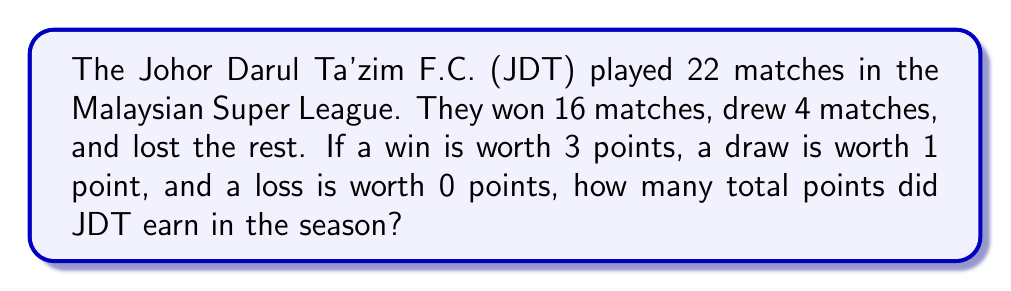What is the answer to this math problem? Let's approach this step-by-step:

1. First, let's identify the given information:
   - Total matches played: 22
   - Matches won: 16
   - Matches drawn: 4
   - Matches lost: 22 - 16 - 4 = 2

2. Now, let's set up our equation:
   $$ \text{Total Points} = (3 \times \text{Wins}) + (1 \times \text{Draws}) + (0 \times \text{Losses}) $$

3. Let's substitute the values:
   $$ \text{Total Points} = (3 \times 16) + (1 \times 4) + (0 \times 2) $$

4. Simplify:
   $$ \text{Total Points} = 48 + 4 + 0 $$

5. Calculate the final result:
   $$ \text{Total Points} = 52 $$

Therefore, JDT earned a total of 52 points in the Malaysian Super League season.
Answer: 52 points 